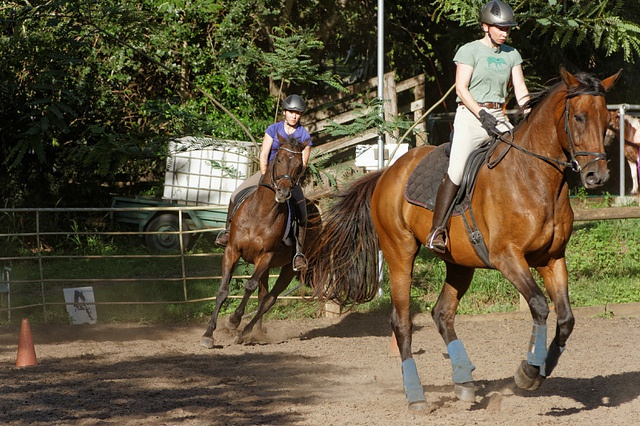Describe the objects in this image and their specific colors. I can see horse in black, brown, maroon, and gray tones, horse in black, maroon, and gray tones, people in black, ivory, gray, and darkgray tones, people in black, gray, and maroon tones, and horse in black, ivory, maroon, and gray tones in this image. 